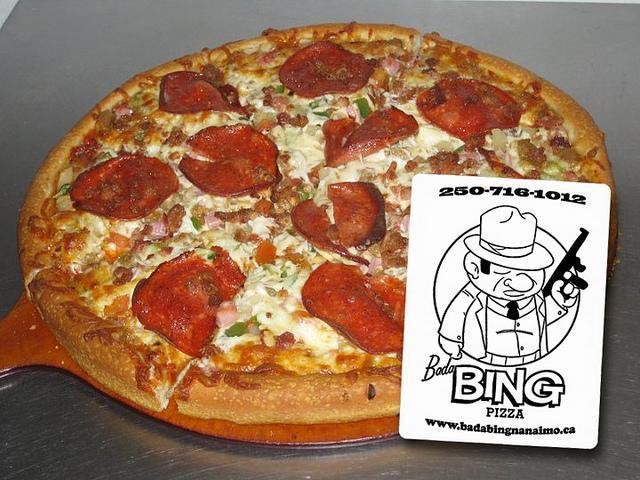How many pizzas are there?
Give a very brief answer. 2. 